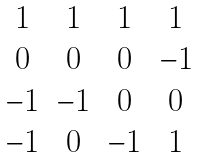<formula> <loc_0><loc_0><loc_500><loc_500>\begin{matrix} 1 & 1 & 1 & 1 \\ 0 & 0 & 0 & - 1 \\ - 1 & - 1 & 0 & 0 \\ - 1 & 0 & - 1 & 1 \end{matrix}</formula> 